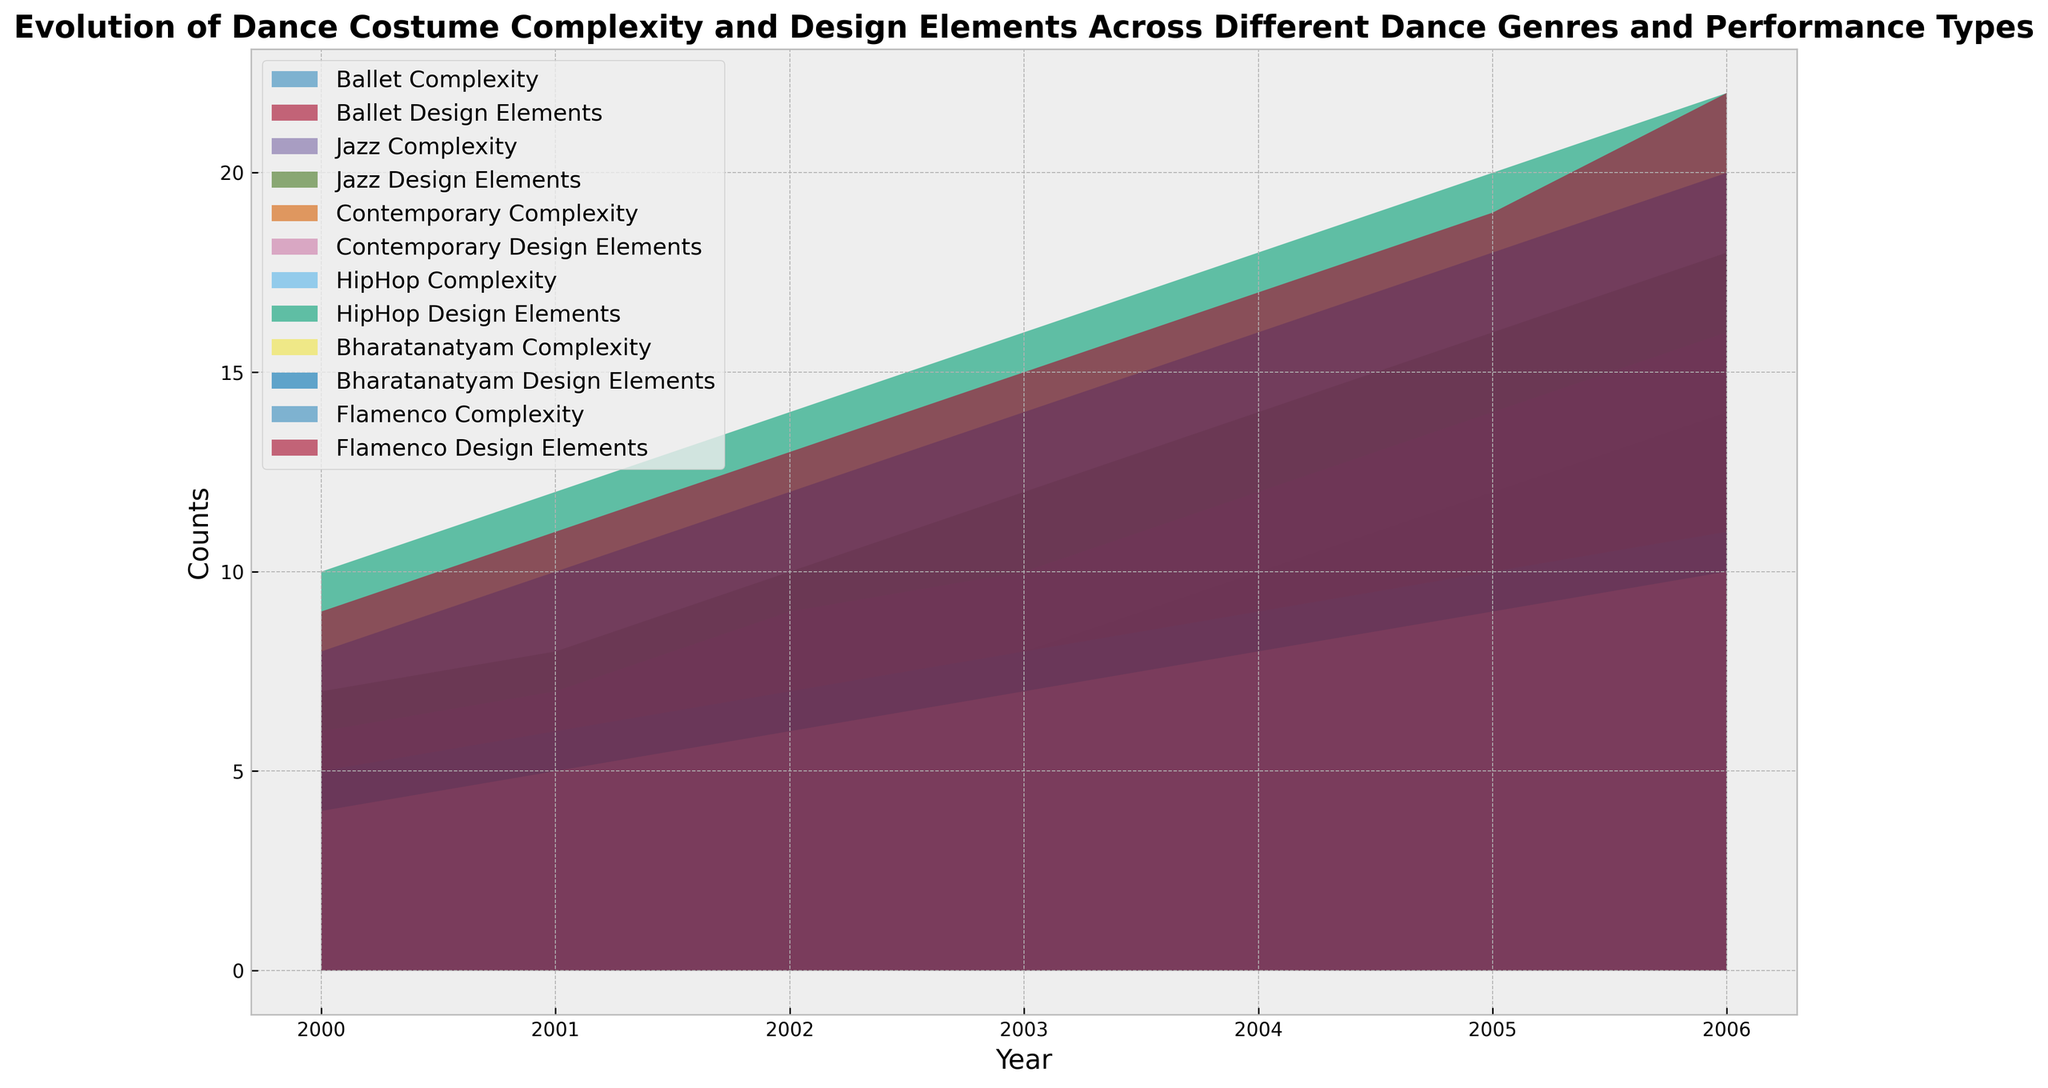What year did Ballet first surpass a Complexity count of 5? Inspecting the areas for Ballet, the Complexity count reaches above 5 in the year 2002.
Answer: 2002 Which dance genre had the highest Design Elements count in 2006? Observing the height of the areas in 2006, the HipHop genre has the highest Design Elements count, reaching 22.
Answer: HipHop How did the Complexity of Bharatanatyam change from 2002 to 2004? Comparing the Complexity count for Bharatanatyam in 2002 (6) and 2004 (8), the Complexity increased by 2 units.
Answer: It increased by 2 Between 2001 and 2003, which genre experienced the largest increase in Design Elements count? By comparing the difference in Design Elements counts from 2001 to 2003 for each genre: Ballet (2), Jazz (4), Contemporary (3), HipHop (4), Bharatanatyam (4), and Flamenco (4), several genres have an equal increase of 4. These are Jazz, HipHop, Bharatanatyam, and Flamenco.
Answer: Jazz, HipHop, Bharatanatyam, and Flamenco What is the total Complexity for all genres combined in the year 2000? Summing up the Complexity counts for each genre in 2000: Ballet (3) + Jazz (4) + Contemporary (3) + HipHop (5) + Bharatanatyam (4) + Flamenco (4) = 23.
Answer: 23 Which genre showed the most consistent increase in Complexity from 2000 to 2006? Observing the smoothness and steepness of the areas for Complexity over the years, Ballet shows a consistent increase each year from 3 in 2000 to 9 in 2006.
Answer: Ballet In what year did all genres combined first exceed a total Design Elements count of 75? Summing the Design Elements for all genres combined: 2004 (10 + 14 + 12 + 18 + 16 + 17 = 87).
Answer: 2004 Between 2000 and 2006, which genre had the lowest average Complexity count? Calculating the average Complexity over the years for each genre: Ballet ((3+4+5+6+7+8+9)/7), Jazz ((4+5+6+7+8+9+10)/7), Contemporary ((3+4+5+6+7+8+9)/7), HipHop ((5+6+7+8+9+10+11)/7), Bharatanatyam ((4+5+6+7+8+9+10)/7), Flamenco ((4+5+6+7+8+9+10)/7), the averages are 6, 7, 6, 8, 7, 7 respectively. Ballet and Contemporary have the lowest average Complexity count at 6.
Answer: Ballet and Contemporary 